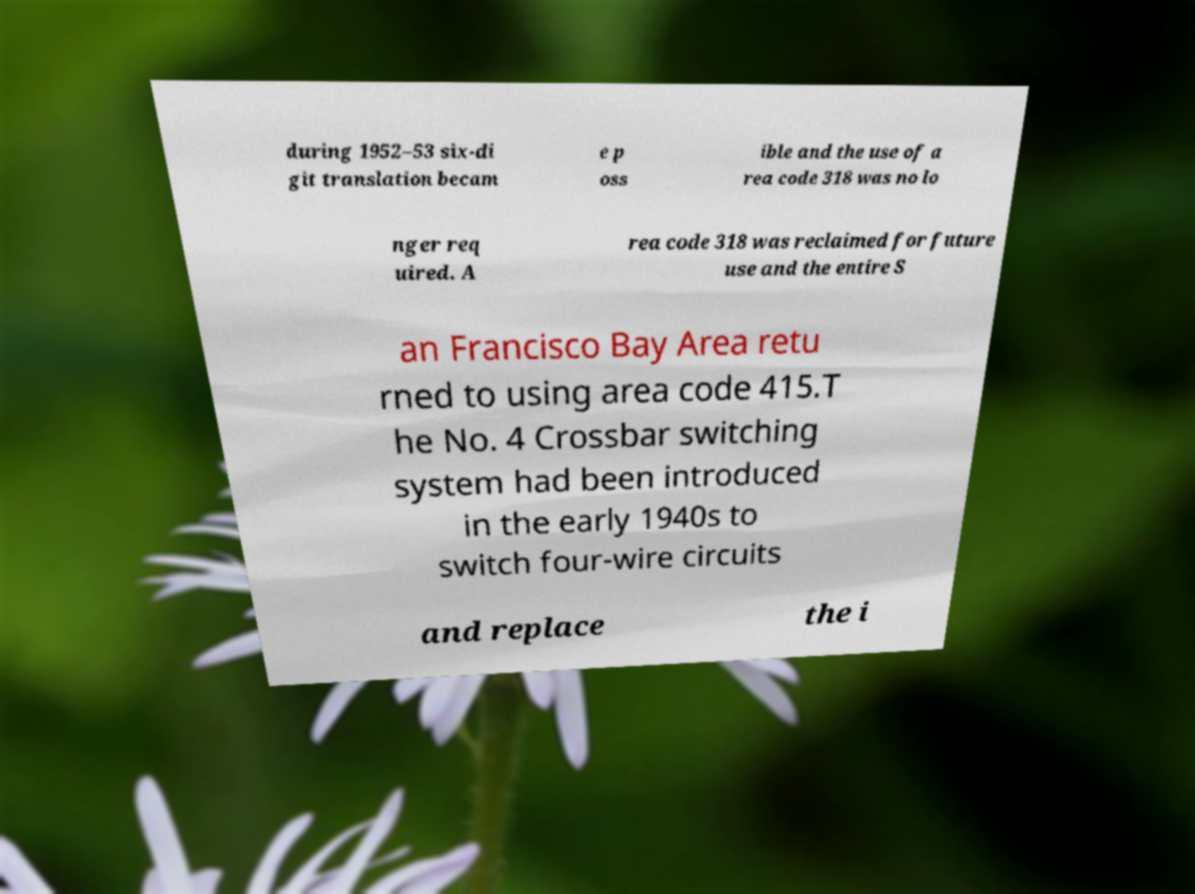For documentation purposes, I need the text within this image transcribed. Could you provide that? during 1952–53 six-di git translation becam e p oss ible and the use of a rea code 318 was no lo nger req uired. A rea code 318 was reclaimed for future use and the entire S an Francisco Bay Area retu rned to using area code 415.T he No. 4 Crossbar switching system had been introduced in the early 1940s to switch four-wire circuits and replace the i 